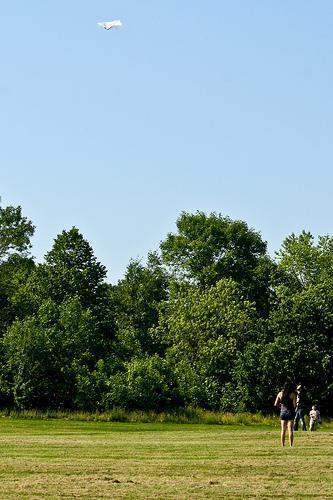How many people are there?
Give a very brief answer. 3. 